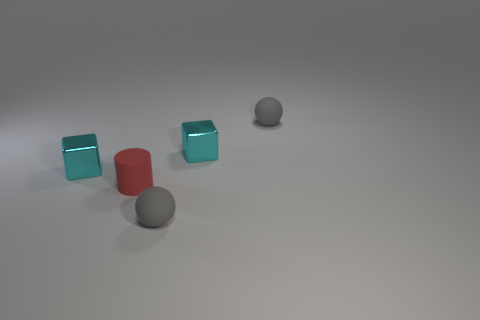Add 1 shiny things. How many objects exist? 6 Subtract 0 blue cylinders. How many objects are left? 5 Subtract all spheres. How many objects are left? 3 Subtract 1 spheres. How many spheres are left? 1 Subtract all green balls. Subtract all gray blocks. How many balls are left? 2 Subtract all red spheres. How many blue blocks are left? 0 Subtract all gray things. Subtract all tiny gray things. How many objects are left? 1 Add 1 rubber cylinders. How many rubber cylinders are left? 2 Add 3 gray cubes. How many gray cubes exist? 3 